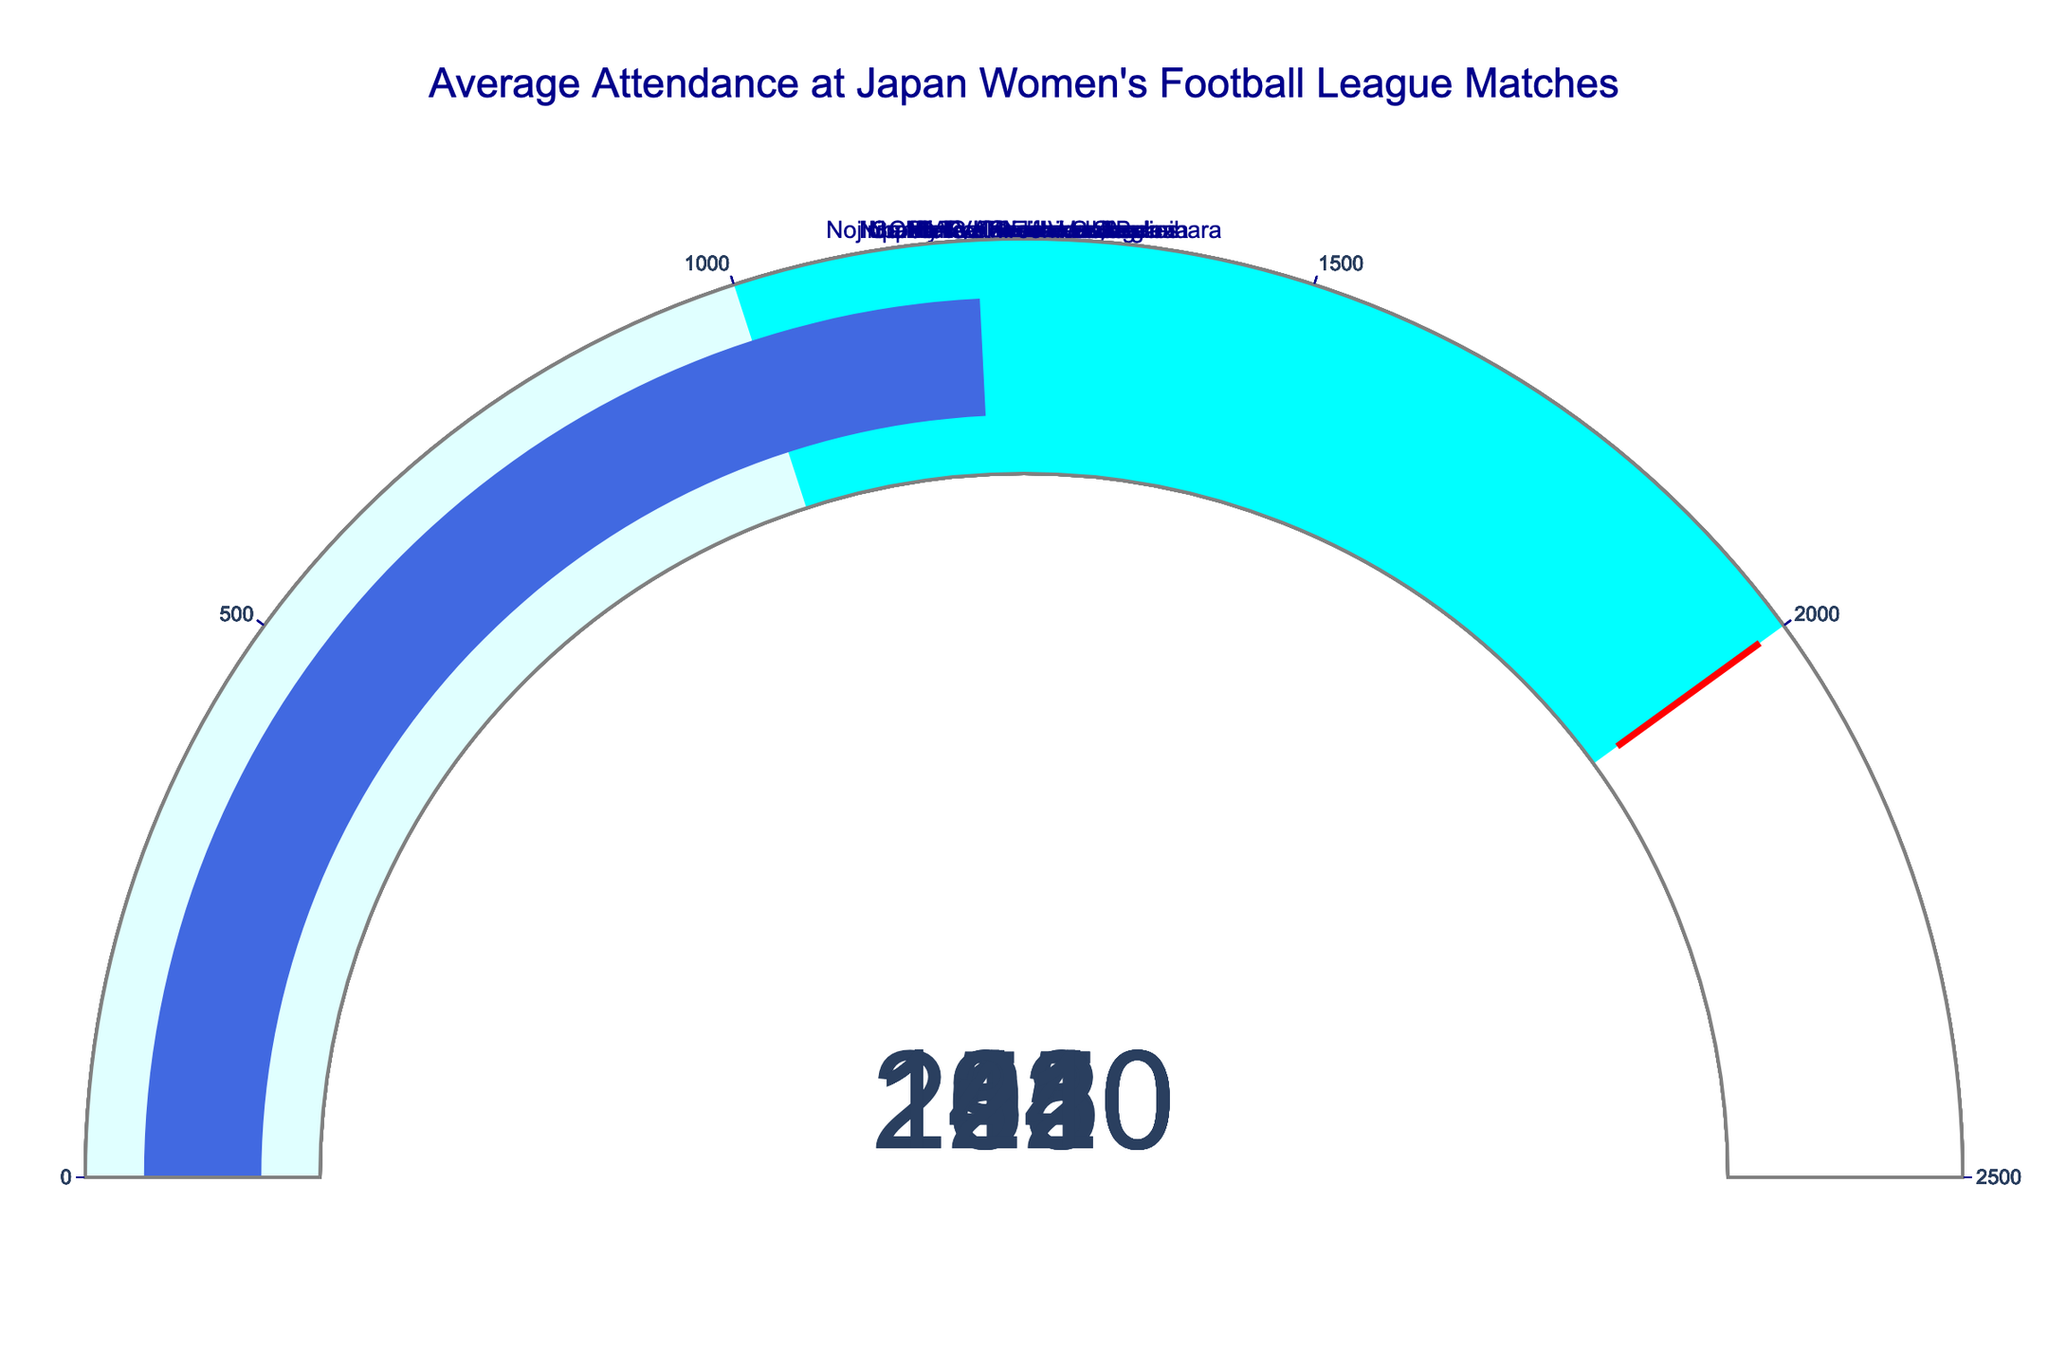Which team has the highest average attendance? To determine the team with the highest average attendance, I look at the numbers displayed on the gauge charts. Urawa Red Diamonds Ladies have the highest value of 2150.
Answer: Urawa Red Diamonds Ladies Which team has the lowest average attendance? To determine the team with the lowest average attendance, I find the smallest value among the gauge charts. Sanfrecce Hiroshima Regina has the lowest value of 1210.
Answer: Sanfrecce Hiroshima Regina What is the average attendance value for all teams combined? I sum up the attendance values of all teams and divide by the number of teams. (2150 + 1980 + 1850 + 1620 + 1540 + 1430 + 1320 + 1210) / 8 = 1512.5
Answer: 1512.5 What is the difference in average attendance between the team with the highest and lowest attendance? Subtract the lowest attendance from the highest attendance. 2150 - 1210 = 940
Answer: 940 How many teams have an average attendance above 1500? By examining the gauge charts, I count the teams with values greater than 1500. The teams are Urawa Red Diamonds Ladies, INAC Kobe Leonessa, Nippon TV Tokyo Verdy Beleza, Mynavi Sendai Ladies, and Nojima Stella Kanagawa Sagamihara, totaling 5 teams.
Answer: 5 Which team is closest to the average attendance value of 2000? By identifying the team with an average attendance nearest to 2000, I find that INAC Kobe Leonessa has an attendance of 1980, which is the closest.
Answer: INAC Kobe Leonessa How much higher is INAC Kobe Leonessa's attendance than Sanfrecce Hiroshima Regina's? Subtract Sanfrecce Hiroshima Regina's attendance from INAC Kobe Leonessa's attendance. 1980 - 1210 = 770
Answer: 770 Are there any teams with an average attendance between 1300 and 1500? If so, which ones? By checking the gauge charts for attendance values between 1300 and 1500, I find that Chifure AS Elfen Saitama and Omiya Ardija Ventus fit this criterion.
Answer: Chifure AS Elfen Saitama, Omiya Ardija Ventus 